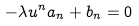Convert formula to latex. <formula><loc_0><loc_0><loc_500><loc_500>- \lambda u ^ { n } a _ { n } + b _ { n } = 0 \\</formula> 